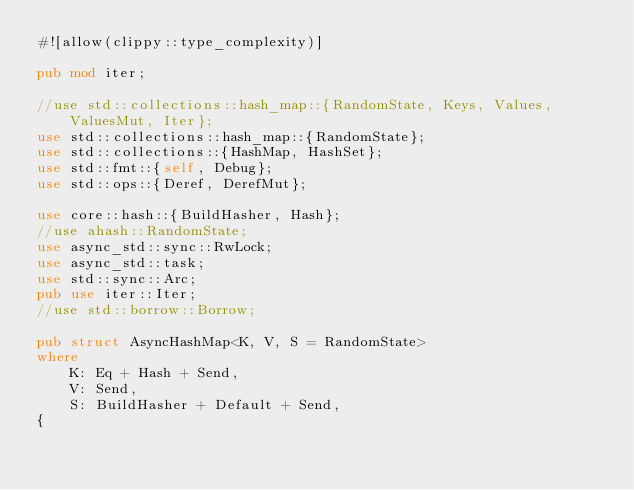<code> <loc_0><loc_0><loc_500><loc_500><_Rust_>#![allow(clippy::type_complexity)]

pub mod iter;

//use std::collections::hash_map::{RandomState, Keys, Values, ValuesMut, Iter};
use std::collections::hash_map::{RandomState};
use std::collections::{HashMap, HashSet};
use std::fmt::{self, Debug};
use std::ops::{Deref, DerefMut};

use core::hash::{BuildHasher, Hash};
//use ahash::RandomState;
use async_std::sync::RwLock;
use async_std::task;
use std::sync::Arc;
pub use iter::Iter;
//use std::borrow::Borrow;

pub struct AsyncHashMap<K, V, S = RandomState>
where
    K: Eq + Hash + Send,
    V: Send,
    S: BuildHasher + Default + Send,
{</code> 